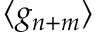<formula> <loc_0><loc_0><loc_500><loc_500>\langle g _ { n + m } \rangle</formula> 